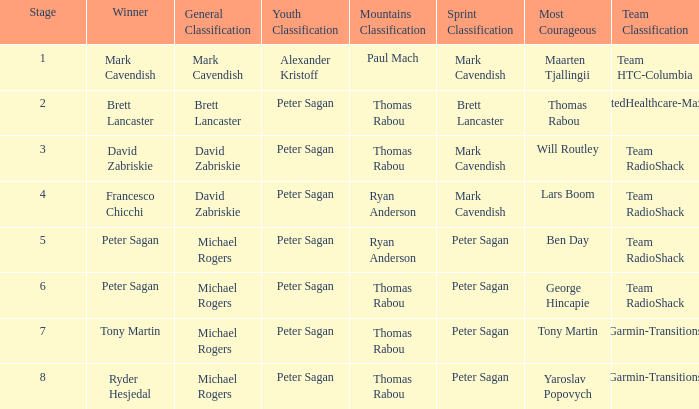Help me parse the entirety of this table. {'header': ['Stage', 'Winner', 'General Classification', 'Youth Classification', 'Mountains Classification', 'Sprint Classification', 'Most Courageous', 'Team Classification'], 'rows': [['1', 'Mark Cavendish', 'Mark Cavendish', 'Alexander Kristoff', 'Paul Mach', 'Mark Cavendish', 'Maarten Tjallingii', 'Team HTC-Columbia'], ['2', 'Brett Lancaster', 'Brett Lancaster', 'Peter Sagan', 'Thomas Rabou', 'Brett Lancaster', 'Thomas Rabou', 'UnitedHealthcare-Maxxis'], ['3', 'David Zabriskie', 'David Zabriskie', 'Peter Sagan', 'Thomas Rabou', 'Mark Cavendish', 'Will Routley', 'Team RadioShack'], ['4', 'Francesco Chicchi', 'David Zabriskie', 'Peter Sagan', 'Ryan Anderson', 'Mark Cavendish', 'Lars Boom', 'Team RadioShack'], ['5', 'Peter Sagan', 'Michael Rogers', 'Peter Sagan', 'Ryan Anderson', 'Peter Sagan', 'Ben Day', 'Team RadioShack'], ['6', 'Peter Sagan', 'Michael Rogers', 'Peter Sagan', 'Thomas Rabou', 'Peter Sagan', 'George Hincapie', 'Team RadioShack'], ['7', 'Tony Martin', 'Michael Rogers', 'Peter Sagan', 'Thomas Rabou', 'Peter Sagan', 'Tony Martin', 'Garmin-Transitions'], ['8', 'Ryder Hesjedal', 'Michael Rogers', 'Peter Sagan', 'Thomas Rabou', 'Peter Sagan', 'Yaroslav Popovych', 'Garmin-Transitions']]} During the time yaroslav popovych was awarded the most courageous title, who was the winner of the mountains classification? Thomas Rabou. 